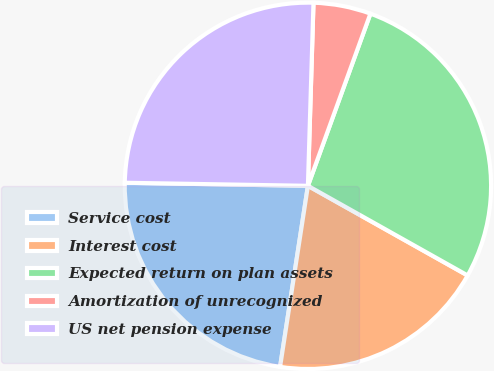Convert chart to OTSL. <chart><loc_0><loc_0><loc_500><loc_500><pie_chart><fcel>Service cost<fcel>Interest cost<fcel>Expected return on plan assets<fcel>Amortization of unrecognized<fcel>US net pension expense<nl><fcel>22.84%<fcel>19.29%<fcel>27.6%<fcel>5.06%<fcel>25.22%<nl></chart> 